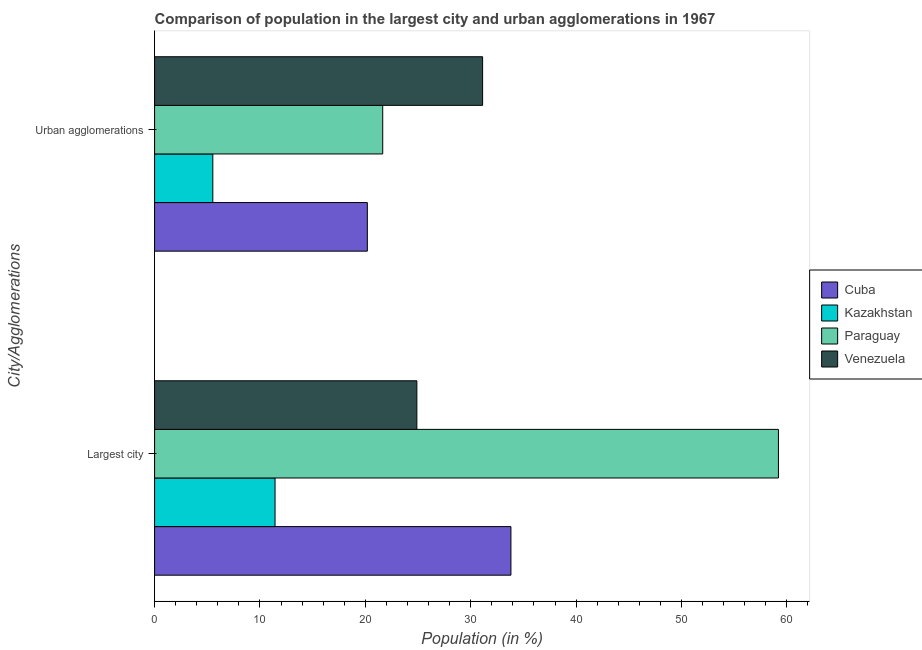How many groups of bars are there?
Ensure brevity in your answer.  2. Are the number of bars per tick equal to the number of legend labels?
Give a very brief answer. Yes. How many bars are there on the 1st tick from the top?
Offer a very short reply. 4. How many bars are there on the 2nd tick from the bottom?
Your answer should be compact. 4. What is the label of the 1st group of bars from the top?
Provide a short and direct response. Urban agglomerations. What is the population in the largest city in Kazakhstan?
Keep it short and to the point. 11.43. Across all countries, what is the maximum population in urban agglomerations?
Your answer should be very brief. 31.13. Across all countries, what is the minimum population in urban agglomerations?
Provide a succinct answer. 5.53. In which country was the population in urban agglomerations maximum?
Offer a terse response. Venezuela. In which country was the population in the largest city minimum?
Provide a short and direct response. Kazakhstan. What is the total population in urban agglomerations in the graph?
Give a very brief answer. 78.49. What is the difference between the population in urban agglomerations in Kazakhstan and that in Cuba?
Provide a succinct answer. -14.66. What is the difference between the population in the largest city in Cuba and the population in urban agglomerations in Venezuela?
Your answer should be compact. 2.69. What is the average population in urban agglomerations per country?
Your answer should be compact. 19.62. What is the difference between the population in the largest city and population in urban agglomerations in Cuba?
Your response must be concise. 13.62. In how many countries, is the population in the largest city greater than 50 %?
Your answer should be very brief. 1. What is the ratio of the population in urban agglomerations in Kazakhstan to that in Paraguay?
Your answer should be very brief. 0.26. What does the 4th bar from the top in Largest city represents?
Ensure brevity in your answer.  Cuba. What does the 4th bar from the bottom in Urban agglomerations represents?
Your response must be concise. Venezuela. Are all the bars in the graph horizontal?
Give a very brief answer. Yes. How many countries are there in the graph?
Your answer should be compact. 4. What is the difference between two consecutive major ticks on the X-axis?
Provide a succinct answer. 10. Does the graph contain any zero values?
Make the answer very short. No. Where does the legend appear in the graph?
Offer a terse response. Center right. What is the title of the graph?
Offer a very short reply. Comparison of population in the largest city and urban agglomerations in 1967. What is the label or title of the X-axis?
Offer a terse response. Population (in %). What is the label or title of the Y-axis?
Offer a very short reply. City/Agglomerations. What is the Population (in %) of Cuba in Largest city?
Offer a terse response. 33.81. What is the Population (in %) of Kazakhstan in Largest city?
Make the answer very short. 11.43. What is the Population (in %) of Paraguay in Largest city?
Your answer should be compact. 59.2. What is the Population (in %) of Venezuela in Largest city?
Your answer should be compact. 24.89. What is the Population (in %) of Cuba in Urban agglomerations?
Make the answer very short. 20.19. What is the Population (in %) in Kazakhstan in Urban agglomerations?
Provide a succinct answer. 5.53. What is the Population (in %) of Paraguay in Urban agglomerations?
Make the answer very short. 21.65. What is the Population (in %) in Venezuela in Urban agglomerations?
Give a very brief answer. 31.13. Across all City/Agglomerations, what is the maximum Population (in %) of Cuba?
Make the answer very short. 33.81. Across all City/Agglomerations, what is the maximum Population (in %) in Kazakhstan?
Your answer should be very brief. 11.43. Across all City/Agglomerations, what is the maximum Population (in %) of Paraguay?
Provide a short and direct response. 59.2. Across all City/Agglomerations, what is the maximum Population (in %) of Venezuela?
Keep it short and to the point. 31.13. Across all City/Agglomerations, what is the minimum Population (in %) in Cuba?
Your response must be concise. 20.19. Across all City/Agglomerations, what is the minimum Population (in %) in Kazakhstan?
Your answer should be very brief. 5.53. Across all City/Agglomerations, what is the minimum Population (in %) in Paraguay?
Provide a short and direct response. 21.65. Across all City/Agglomerations, what is the minimum Population (in %) in Venezuela?
Provide a short and direct response. 24.89. What is the total Population (in %) of Cuba in the graph?
Ensure brevity in your answer.  54. What is the total Population (in %) in Kazakhstan in the graph?
Provide a succinct answer. 16.96. What is the total Population (in %) of Paraguay in the graph?
Provide a succinct answer. 80.85. What is the total Population (in %) of Venezuela in the graph?
Your answer should be very brief. 56.02. What is the difference between the Population (in %) of Cuba in Largest city and that in Urban agglomerations?
Give a very brief answer. 13.62. What is the difference between the Population (in %) in Kazakhstan in Largest city and that in Urban agglomerations?
Your answer should be very brief. 5.9. What is the difference between the Population (in %) of Paraguay in Largest city and that in Urban agglomerations?
Offer a very short reply. 37.55. What is the difference between the Population (in %) of Venezuela in Largest city and that in Urban agglomerations?
Make the answer very short. -6.24. What is the difference between the Population (in %) of Cuba in Largest city and the Population (in %) of Kazakhstan in Urban agglomerations?
Offer a very short reply. 28.29. What is the difference between the Population (in %) of Cuba in Largest city and the Population (in %) of Paraguay in Urban agglomerations?
Provide a short and direct response. 12.16. What is the difference between the Population (in %) of Cuba in Largest city and the Population (in %) of Venezuela in Urban agglomerations?
Provide a short and direct response. 2.69. What is the difference between the Population (in %) in Kazakhstan in Largest city and the Population (in %) in Paraguay in Urban agglomerations?
Provide a short and direct response. -10.22. What is the difference between the Population (in %) of Kazakhstan in Largest city and the Population (in %) of Venezuela in Urban agglomerations?
Offer a terse response. -19.7. What is the difference between the Population (in %) of Paraguay in Largest city and the Population (in %) of Venezuela in Urban agglomerations?
Provide a succinct answer. 28.07. What is the average Population (in %) in Cuba per City/Agglomerations?
Ensure brevity in your answer.  27. What is the average Population (in %) of Kazakhstan per City/Agglomerations?
Provide a short and direct response. 8.48. What is the average Population (in %) of Paraguay per City/Agglomerations?
Offer a terse response. 40.42. What is the average Population (in %) in Venezuela per City/Agglomerations?
Make the answer very short. 28.01. What is the difference between the Population (in %) in Cuba and Population (in %) in Kazakhstan in Largest city?
Keep it short and to the point. 22.38. What is the difference between the Population (in %) of Cuba and Population (in %) of Paraguay in Largest city?
Give a very brief answer. -25.38. What is the difference between the Population (in %) in Cuba and Population (in %) in Venezuela in Largest city?
Provide a succinct answer. 8.93. What is the difference between the Population (in %) in Kazakhstan and Population (in %) in Paraguay in Largest city?
Your answer should be compact. -47.77. What is the difference between the Population (in %) of Kazakhstan and Population (in %) of Venezuela in Largest city?
Ensure brevity in your answer.  -13.46. What is the difference between the Population (in %) of Paraguay and Population (in %) of Venezuela in Largest city?
Provide a succinct answer. 34.31. What is the difference between the Population (in %) in Cuba and Population (in %) in Kazakhstan in Urban agglomerations?
Offer a terse response. 14.66. What is the difference between the Population (in %) in Cuba and Population (in %) in Paraguay in Urban agglomerations?
Give a very brief answer. -1.46. What is the difference between the Population (in %) in Cuba and Population (in %) in Venezuela in Urban agglomerations?
Offer a very short reply. -10.94. What is the difference between the Population (in %) of Kazakhstan and Population (in %) of Paraguay in Urban agglomerations?
Make the answer very short. -16.12. What is the difference between the Population (in %) in Kazakhstan and Population (in %) in Venezuela in Urban agglomerations?
Your answer should be compact. -25.6. What is the difference between the Population (in %) in Paraguay and Population (in %) in Venezuela in Urban agglomerations?
Give a very brief answer. -9.48. What is the ratio of the Population (in %) of Cuba in Largest city to that in Urban agglomerations?
Your answer should be compact. 1.67. What is the ratio of the Population (in %) of Kazakhstan in Largest city to that in Urban agglomerations?
Your answer should be compact. 2.07. What is the ratio of the Population (in %) of Paraguay in Largest city to that in Urban agglomerations?
Make the answer very short. 2.73. What is the ratio of the Population (in %) of Venezuela in Largest city to that in Urban agglomerations?
Ensure brevity in your answer.  0.8. What is the difference between the highest and the second highest Population (in %) in Cuba?
Ensure brevity in your answer.  13.62. What is the difference between the highest and the second highest Population (in %) of Kazakhstan?
Your response must be concise. 5.9. What is the difference between the highest and the second highest Population (in %) of Paraguay?
Offer a terse response. 37.55. What is the difference between the highest and the second highest Population (in %) of Venezuela?
Provide a short and direct response. 6.24. What is the difference between the highest and the lowest Population (in %) in Cuba?
Your response must be concise. 13.62. What is the difference between the highest and the lowest Population (in %) in Kazakhstan?
Offer a terse response. 5.9. What is the difference between the highest and the lowest Population (in %) of Paraguay?
Provide a succinct answer. 37.55. What is the difference between the highest and the lowest Population (in %) in Venezuela?
Keep it short and to the point. 6.24. 